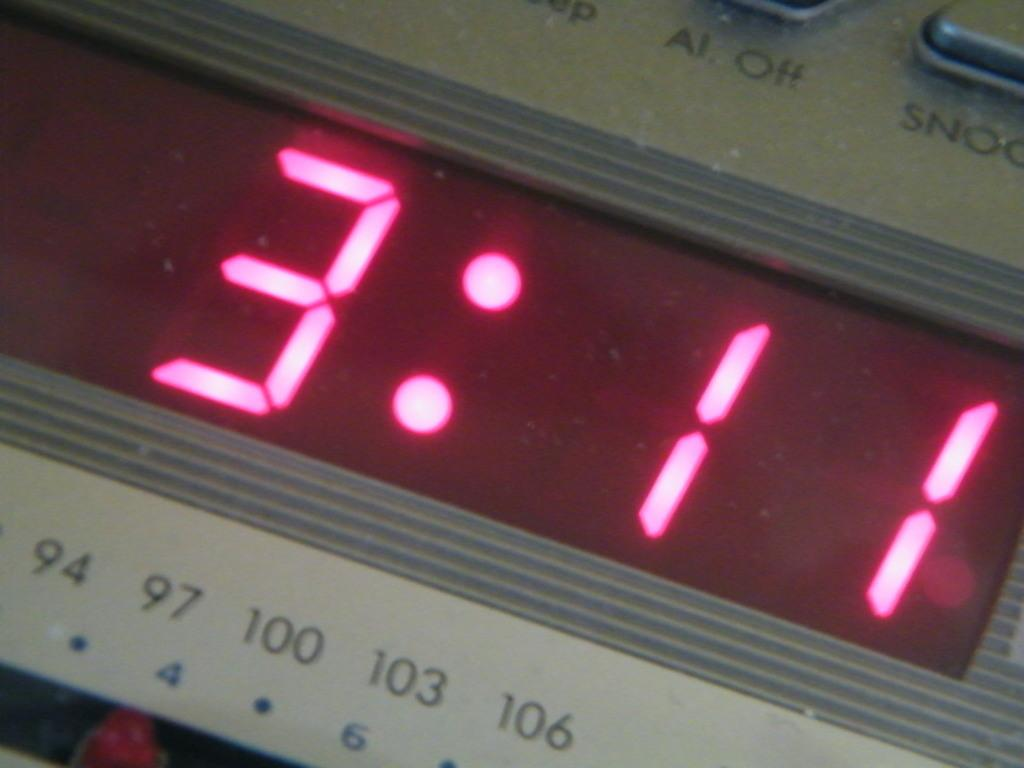<image>
Describe the image concisely. A digital clock displauing the time in red numbers 